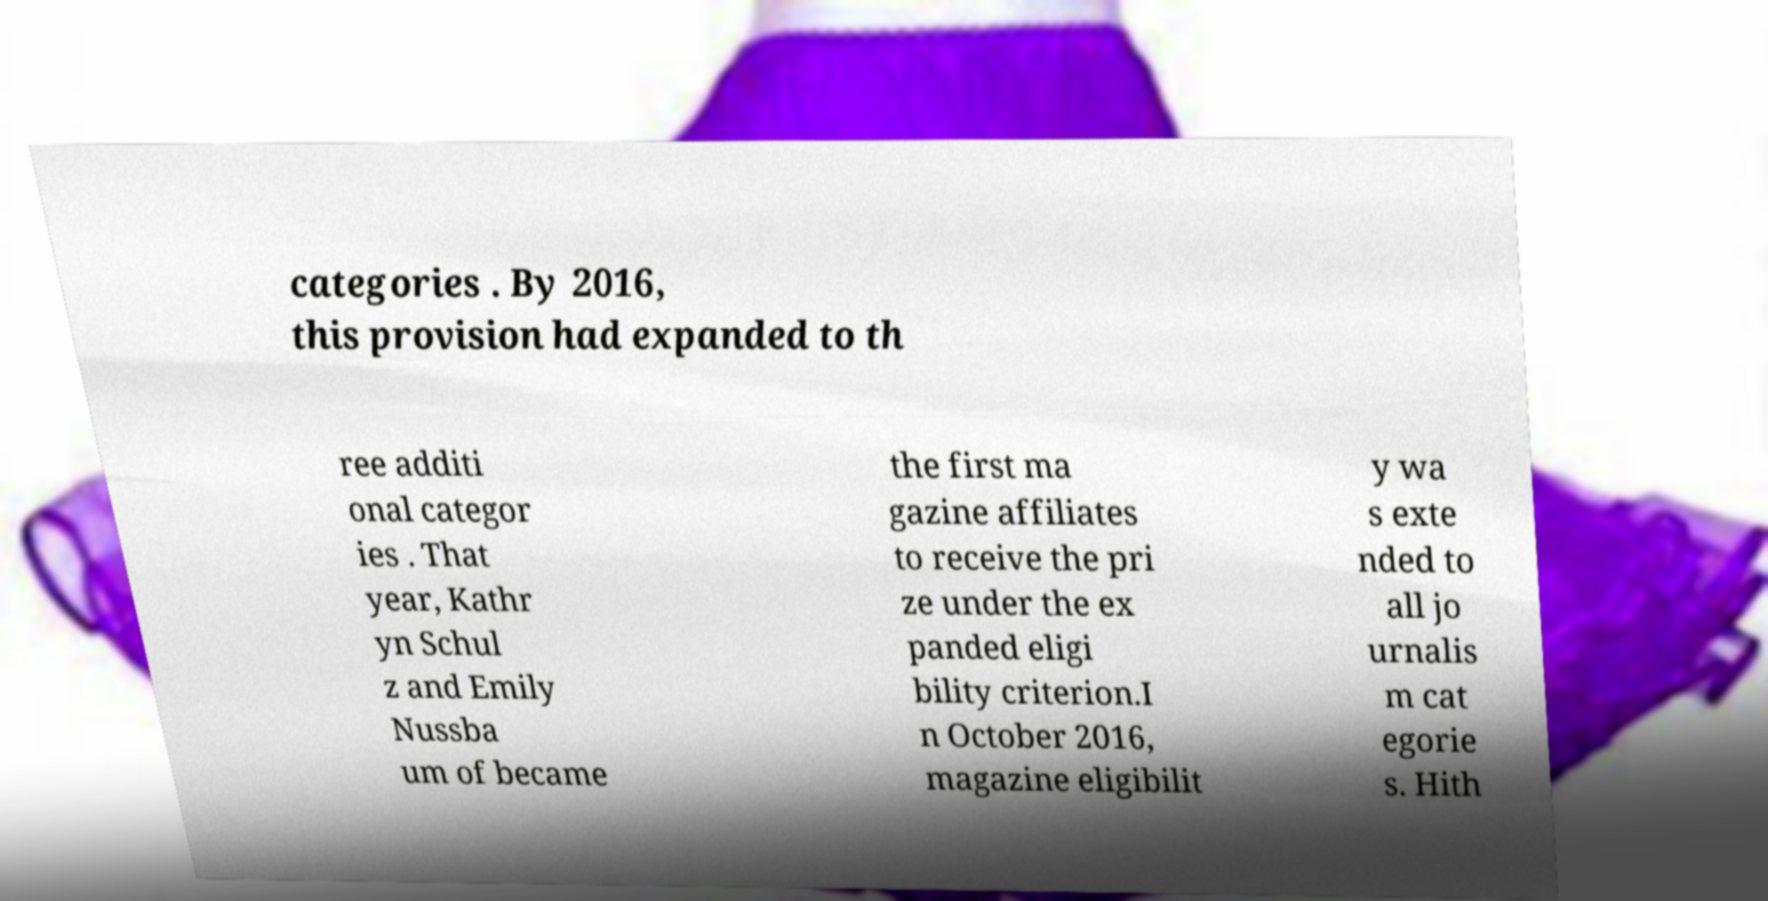What messages or text are displayed in this image? I need them in a readable, typed format. categories . By 2016, this provision had expanded to th ree additi onal categor ies . That year, Kathr yn Schul z and Emily Nussba um of became the first ma gazine affiliates to receive the pri ze under the ex panded eligi bility criterion.I n October 2016, magazine eligibilit y wa s exte nded to all jo urnalis m cat egorie s. Hith 